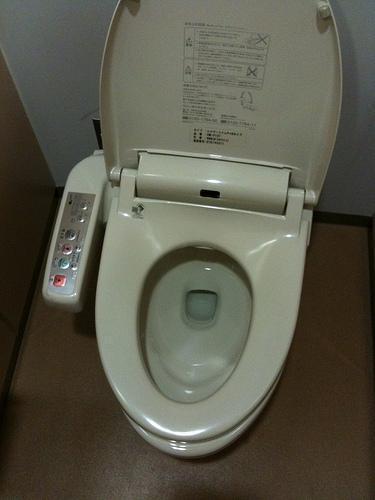How many toilets are there?
Give a very brief answer. 1. 